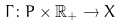Convert formula to latex. <formula><loc_0><loc_0><loc_500><loc_500>\Gamma \colon P \times \mathbb { R } _ { + } \rightarrow X</formula> 